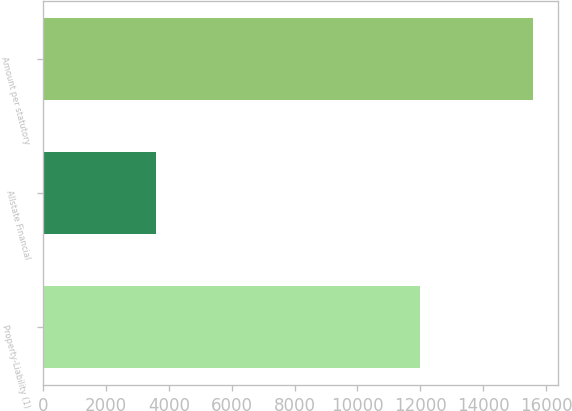<chart> <loc_0><loc_0><loc_500><loc_500><bar_chart><fcel>Property-Liability (1)<fcel>Allstate Financial<fcel>Amount per statutory<nl><fcel>11992<fcel>3600<fcel>15592<nl></chart> 